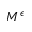Convert formula to latex. <formula><loc_0><loc_0><loc_500><loc_500>M ^ { \epsilon }</formula> 